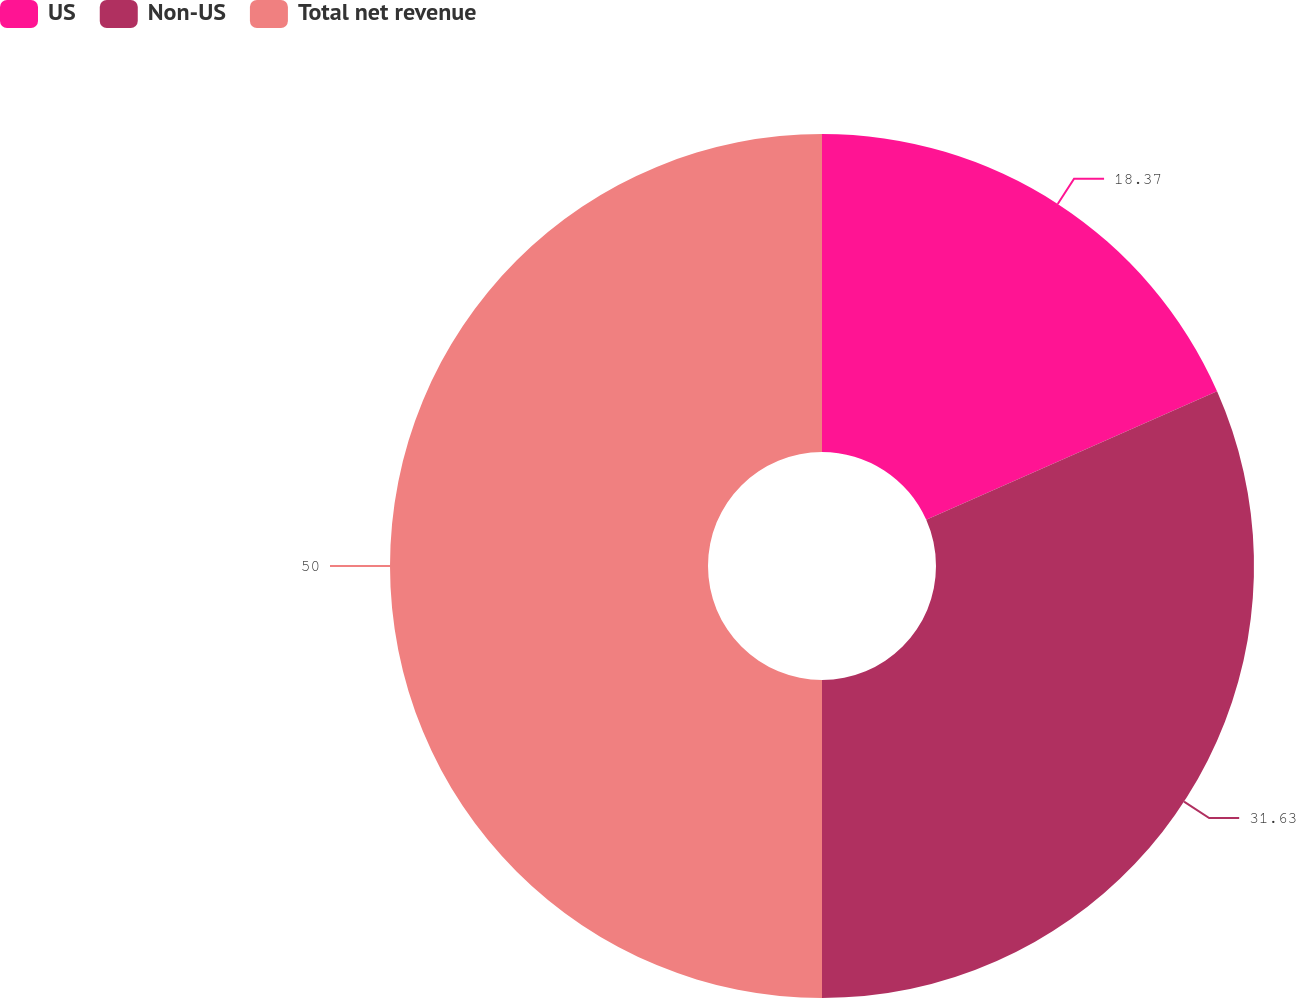Convert chart. <chart><loc_0><loc_0><loc_500><loc_500><pie_chart><fcel>US<fcel>Non-US<fcel>Total net revenue<nl><fcel>18.37%<fcel>31.63%<fcel>50.0%<nl></chart> 